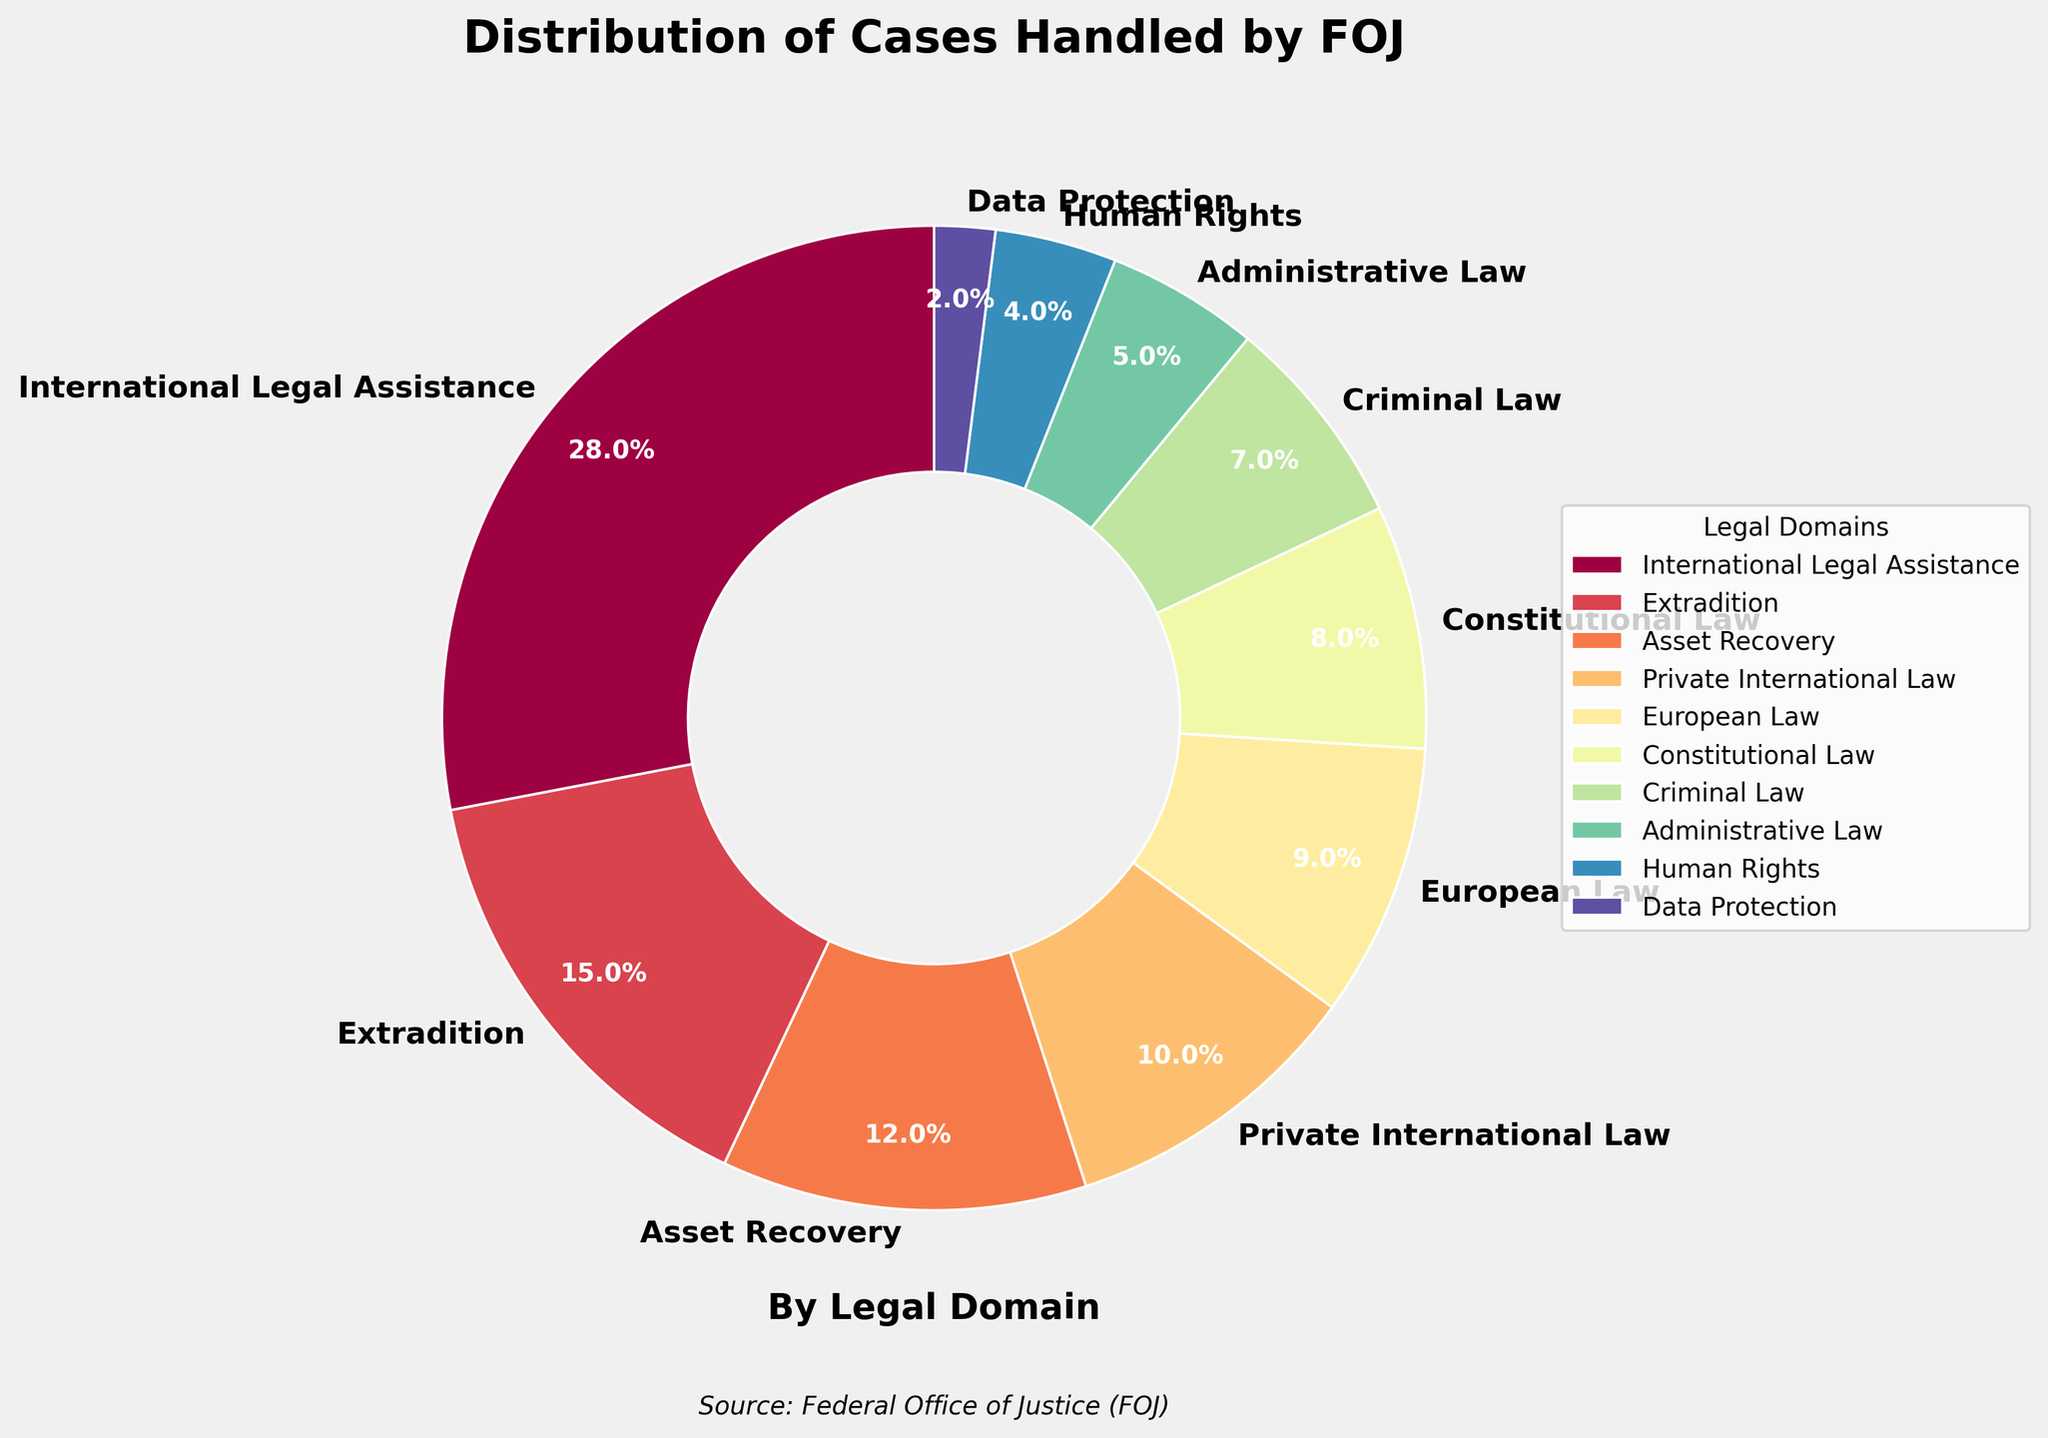Which legal domain has the largest percentage of cases handled by the FOJ? Looking at the pie chart, the largest wedge corresponds to the domain labeled "International Legal Assistance," which is 28%.
Answer: International Legal Assistance By how much does the percentage of cases for Extradition exceed the percentage for Administrative Law? Extradition accounts for 15% of cases, while Administrative Law accounts for 5%. So, 15% - 5% = 10%.
Answer: 10% What is the combined percentage of cases handled by the FOJ concerning European Law and Constitutional Law? European Law accounts for 9% and Constitutional Law for 8%. The combined percentage is 9% + 8% = 17%.
Answer: 17% Which legal domain has the smallest percentage of cases? The smallest wedge in the pie chart is the one representing "Data Protection," which has a 2% share.
Answer: Data Protection Are there more cases handled in the domain of Private International Law or Criminal Law? Private International Law stands at 10%, while Criminal Law is at 7%. Given 10% > 7%, Private International Law has more cases.
Answer: Private International Law What is the difference between the proportion of cases in Human Rights and the combined proportion in Private International Law and Asset Recovery? Human Rights accounts for 4% of the cases. Private International Law and Asset Recovery account for 22% combined (10% + 12%). The difference is 22% - 4% = 18%.
Answer: 18% Compare the combined percentage of cases in Criminal Law and Administrative Law to those in Extradition. Which is higher and by how much? Criminal Law + Administrative Law = 7% + 5% = 12%. Extradition is 15%. The difference is 15% - 12% = 3%, making Extradition higher by 3%.
Answer: Extradition by 3% What is the average percentage of cases per legal domain covered in this pie chart? Adding all the percentages: 28% + 15% + 12% + 10% + 9% + 8% + 7% + 5% + 4% + 2% = 100%. Dividing by the number of domains (10) yields an average of 10%.
Answer: 10% How does the percentage of International Legal Assistance cases compare to the sum of Constitutional Law and Human Rights cases? International Legal Assistance is 28%, while the sum of Constitutional Law and Human Rights is 8% + 4% = 12%. Comparing, 28% is larger than 12%.
Answer: International Legal Assistance is larger 